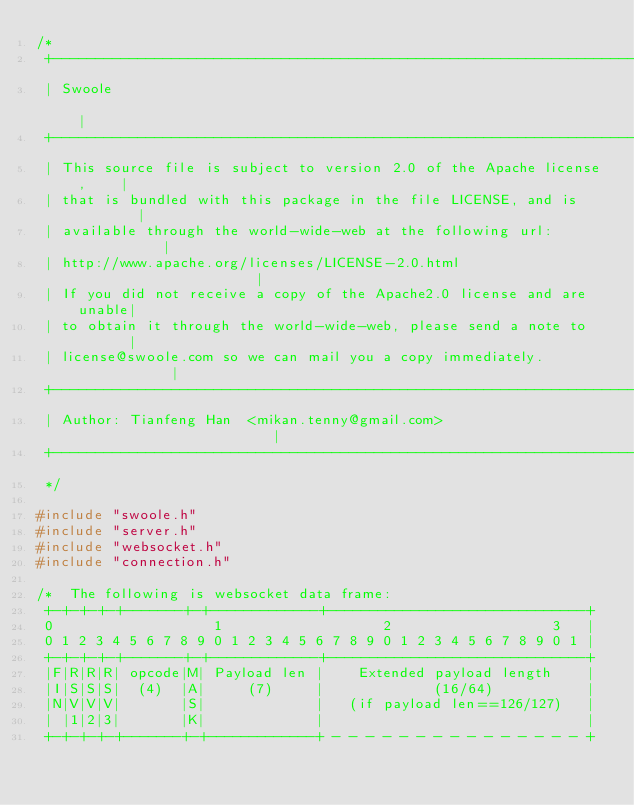Convert code to text. <code><loc_0><loc_0><loc_500><loc_500><_C_>/*
 +----------------------------------------------------------------------+
 | Swoole                                                               |
 +----------------------------------------------------------------------+
 | This source file is subject to version 2.0 of the Apache license,    |
 | that is bundled with this package in the file LICENSE, and is        |
 | available through the world-wide-web at the following url:           |
 | http://www.apache.org/licenses/LICENSE-2.0.html                      |
 | If you did not receive a copy of the Apache2.0 license and are unable|
 | to obtain it through the world-wide-web, please send a note to       |
 | license@swoole.com so we can mail you a copy immediately.            |
 +----------------------------------------------------------------------+
 | Author: Tianfeng Han  <mikan.tenny@gmail.com>                        |
 +----------------------------------------------------------------------+
 */

#include "swoole.h"
#include "server.h"
#include "websocket.h"
#include "connection.h"

/*  The following is websocket data frame:
 +-+-+-+-+-------+-+-------------+-------------------------------+
 0                   1                   2                   3   |
 0 1 2 3 4 5 6 7 8 9 0 1 2 3 4 5 6 7 8 9 0 1 2 3 4 5 6 7 8 9 0 1 |
 +-+-+-+-+-------+-+-------------+-------------------------------+
 |F|R|R|R| opcode|M| Payload len |    Extended payload length    |
 |I|S|S|S|  (4)  |A|     (7)     |             (16/64)           |
 |N|V|V|V|       |S|             |   (if payload len==126/127)   |
 | |1|2|3|       |K|             |                               |
 +-+-+-+-+-------+-+-------------+ - - - - - - - - - - - - - - - +</code> 